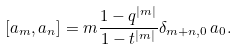Convert formula to latex. <formula><loc_0><loc_0><loc_500><loc_500>[ a _ { m } , a _ { n } ] = m \frac { 1 - q ^ { | m | } } { 1 - t ^ { | m | } } \delta _ { m + n , 0 } \, a _ { 0 } .</formula> 